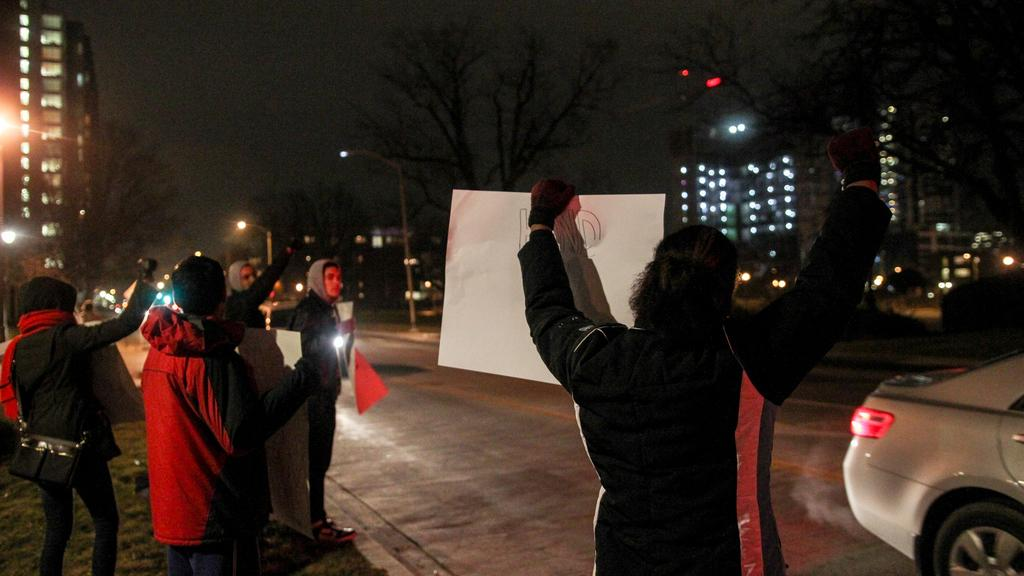What type of structures can be seen in the image? There are buildings in the image. What type of lighting is present in the image? There are street lights in the image. What type of vegetation is present in the image? There are many trees in the image. Where are the people located in the image? A group of people are standing at the rightmost part of the image. What are the people holding in the image? The people are holding objects. Can you tell me how many sisters are present in the image? There is no mention of a sister or any family members in the image. Why are the people crying in the image? There is no indication that anyone is crying in the image; the people are holding objects. 